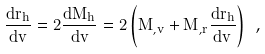<formula> <loc_0><loc_0><loc_500><loc_500>\frac { d r _ { h } } { d v } = 2 \frac { d M _ { h } } { d v } = 2 \left ( M _ { , v } + M _ { , r } \frac { d r _ { h } } { d v } \right ) \ ,</formula> 